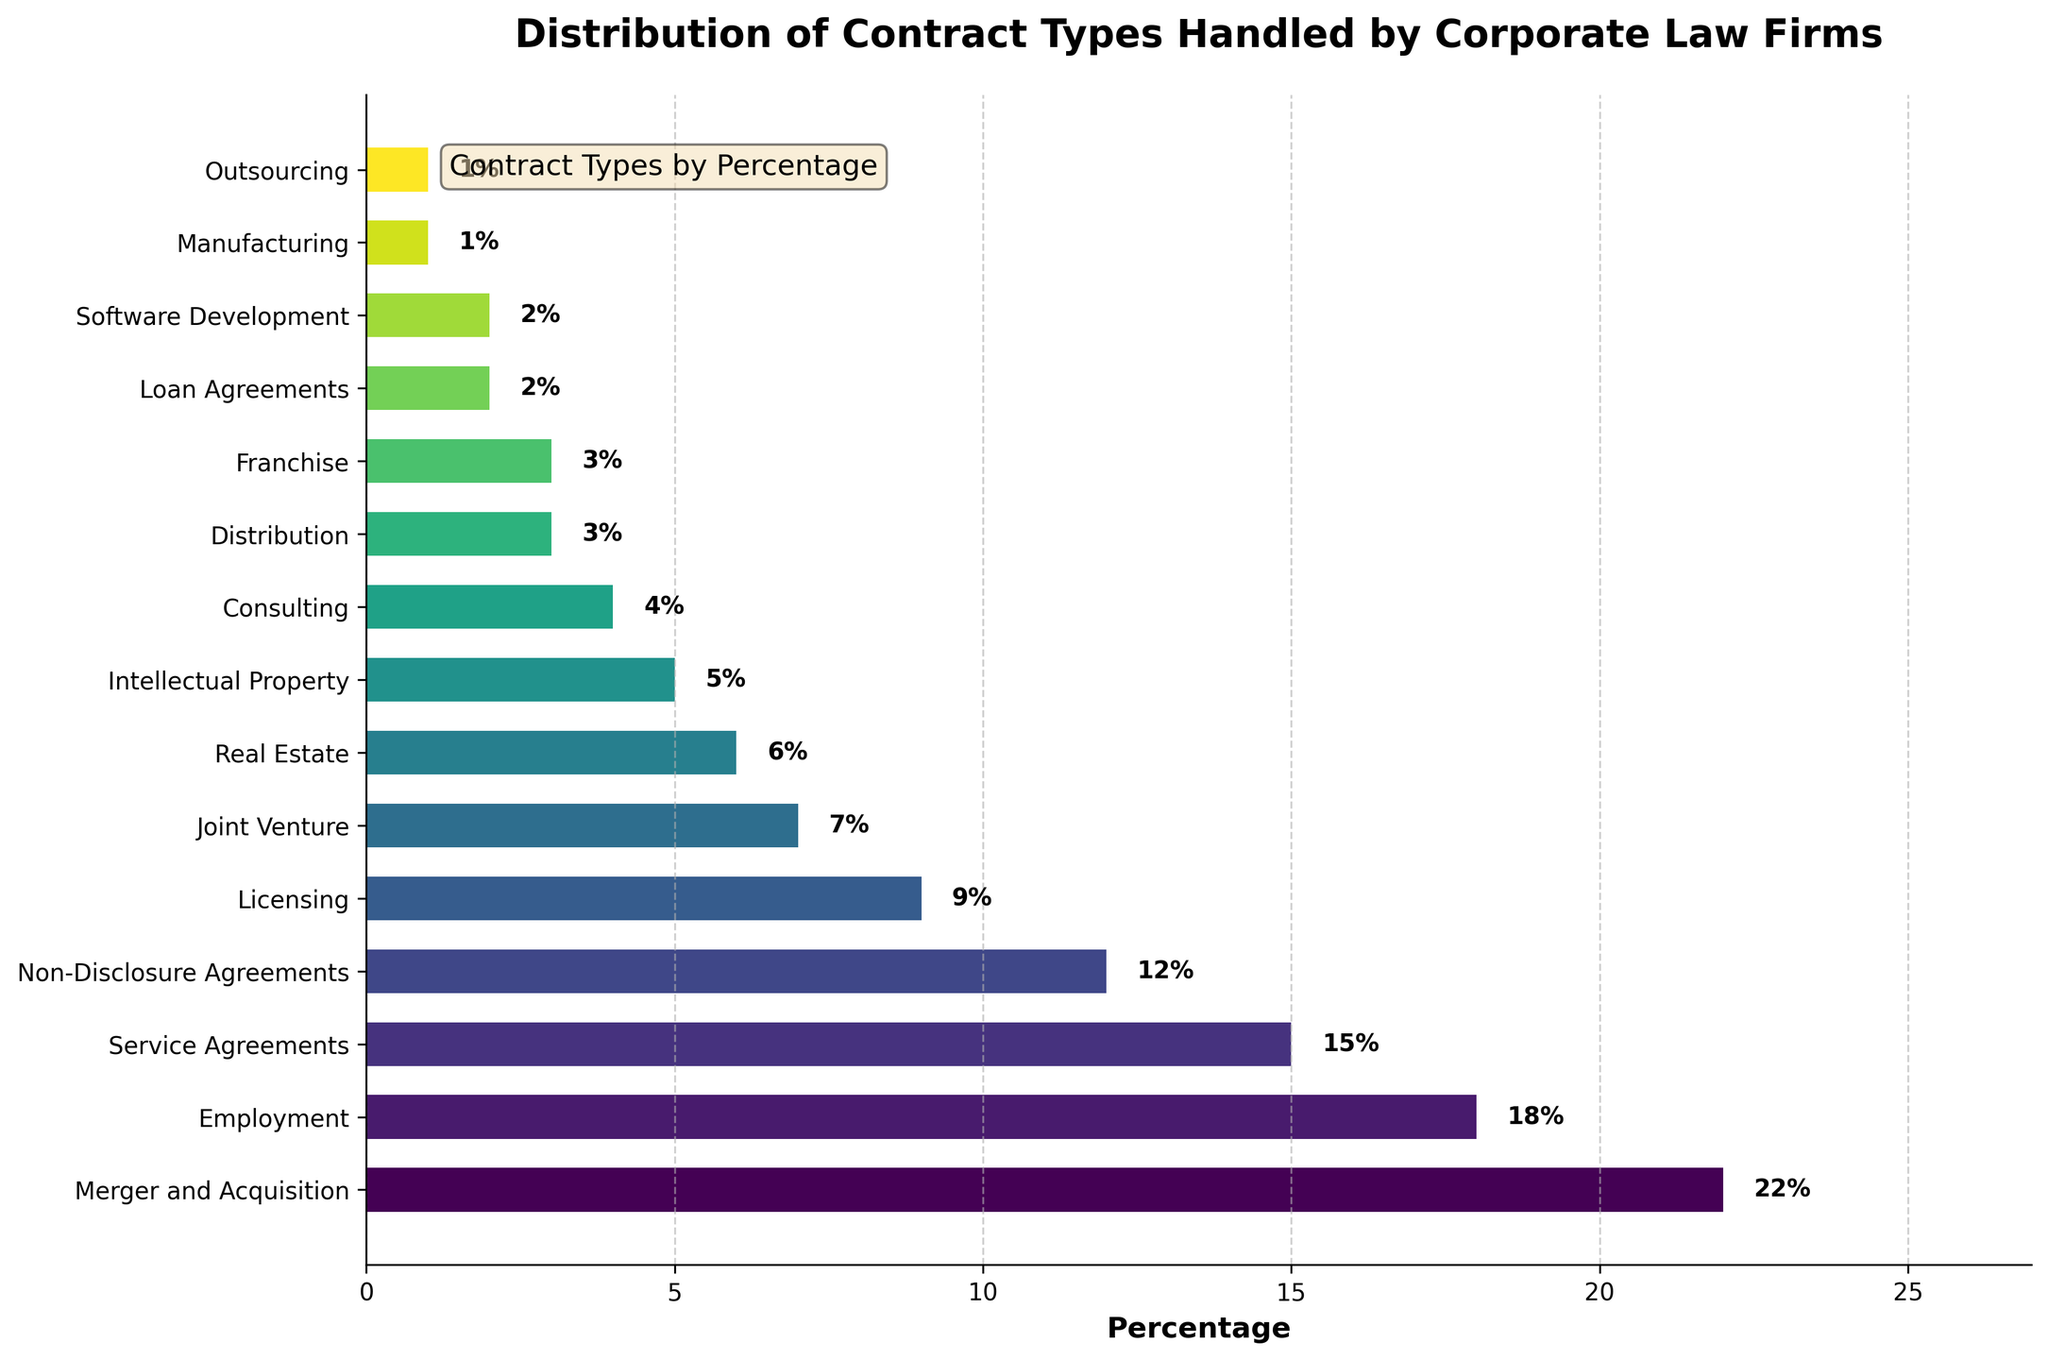What contract type has the highest percentage? The bar representing "Merger and Acquisition" is the longest, indicating the highest percentage. This percentage is clearly labeled as 22% on the bar.
Answer: Merger and Acquisition Which contract types have the same percentage and what is that percentage? Observing the bars of equal length, the bars for "Distribution" and "Franchise" are both labeled with the same percentage, which is 3%.
Answer: Distribution, Franchise, 3% What's the combined percentage of Employment, Service Agreements, and Non-Disclosure Agreements? Add the percentages for Employment (18%), Service Agreements (15%), and Non-Disclosure Agreements (12%): 18 + 15 + 12 = 45.
Answer: 45% What is the difference in percentage between Licensing and Joint Venture contracts? Subtract the percentage for Joint Venture (7%) from Licensing (9%): 9 - 7 = 2.
Answer: 2% What type of contracts appear in the bottom five based on their percentage? The shortest bars and lowest percentages represent the bottom five types, which are Consulting (4%), Distribution (3%), Franchise (3%), Loan Agreements (2%), Software Development (2%), Manufacturing (1%), and Outsourcing (1%). This has seven total, so the bottom five exclude Consulting and Distribution.
Answer: Franchise, Loan Agreements, Software Development, Manufacturing, Outsourcing Which contract type related to property has the lowest percentage and what is it? Observing the bars related to property, "Real Estate" has a higher percentage than "Intellectual Property," which has the lowest at 5%.
Answer: Intellectual Property, 5% Are there more types of contracts above or below the 5% threshold? Count the number of bars above 5% (1. Merger and Acquisition, 2. Employment, 3. Service Agreements, 4. Non-Disclosure Agreements, 5. Licensing, 6. Joint Venture, 7. Real Estate - 7 bars) and those at or below 5% (1. Intellectual Property, 2. Consulting, 3. Distribution, 4. Franchise, 5. Loan Agreements, 6. Software Development, 7. Manufacturing, 8. Outsourcing - 8 bars).
Answer: More below, 8 What is the cumulative percentage of all contract types that are 10% or higher? Add the percentages for Merger and Acquisition (22%), Employment (18%), Service Agreements (15%), and Non-Disclosure Agreements (12%): 22 + 18 + 15 + 12 = 67.
Answer: 67% How many contract types have a percentage lower than 10%? Counting all bars with a percentage lower than 10% (1. Licensing, 2. Joint Venture, 3. Real Estate, 4. Intellectual Property, 5. Consulting, 6. Distribution, 7. Franchise, 8. Loan Agreements, 9. Software Development, 10. Manufacturing, 11. Outsourcing) gives 11.
Answer: 11 